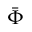<formula> <loc_0><loc_0><loc_500><loc_500>\ B a r { \Phi }</formula> 